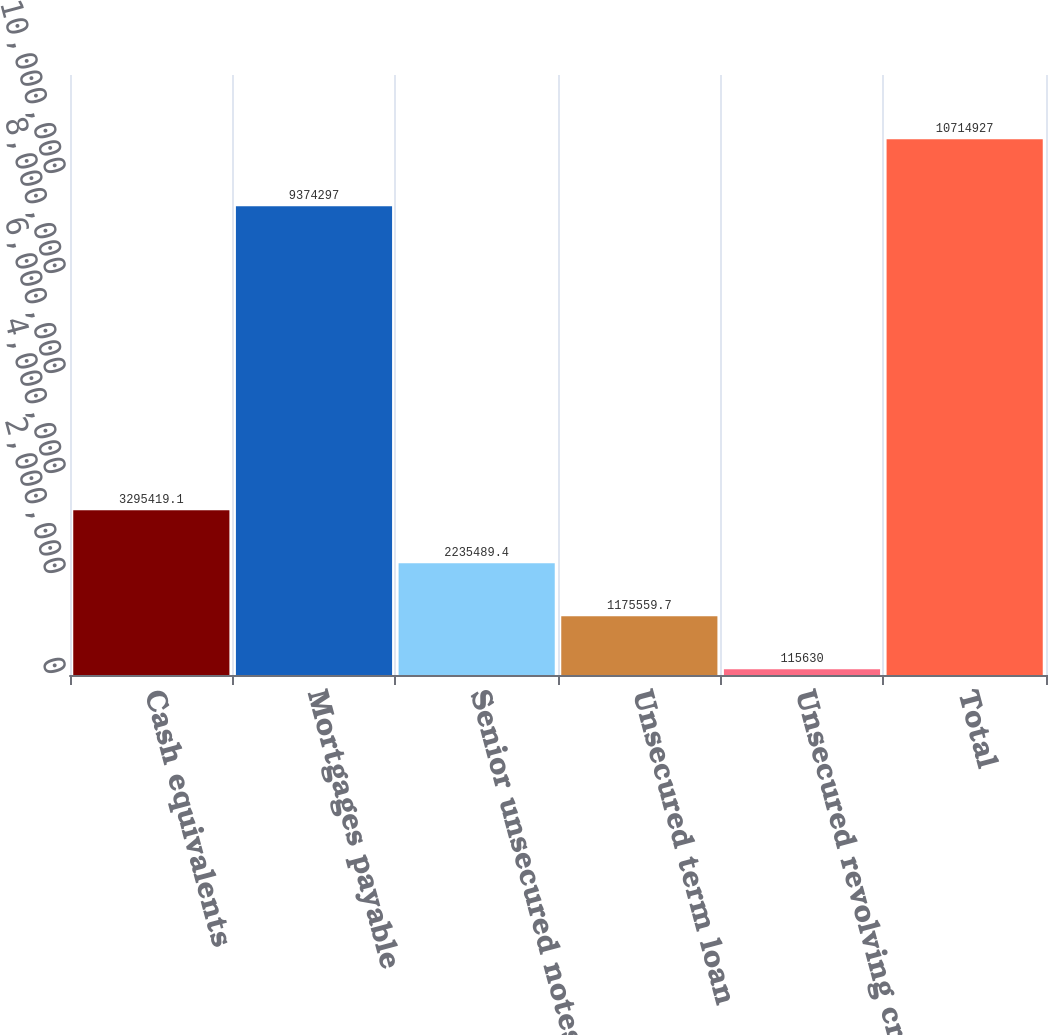Convert chart to OTSL. <chart><loc_0><loc_0><loc_500><loc_500><bar_chart><fcel>Cash equivalents<fcel>Mortgages payable<fcel>Senior unsecured notes<fcel>Unsecured term loan<fcel>Unsecured revolving credit<fcel>Total<nl><fcel>3.29542e+06<fcel>9.3743e+06<fcel>2.23549e+06<fcel>1.17556e+06<fcel>115630<fcel>1.07149e+07<nl></chart> 